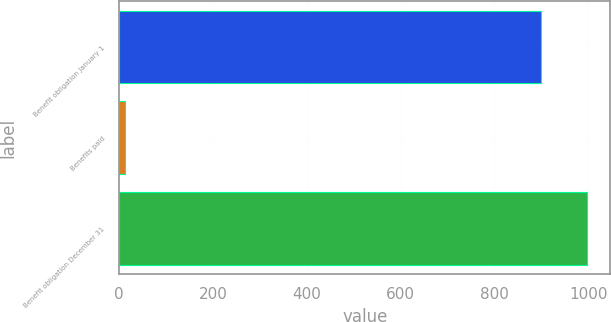Convert chart to OTSL. <chart><loc_0><loc_0><loc_500><loc_500><bar_chart><fcel>Benefit obligation January 1<fcel>Benefits paid<fcel>Benefit obligation December 31<nl><fcel>899<fcel>12<fcel>997.3<nl></chart> 